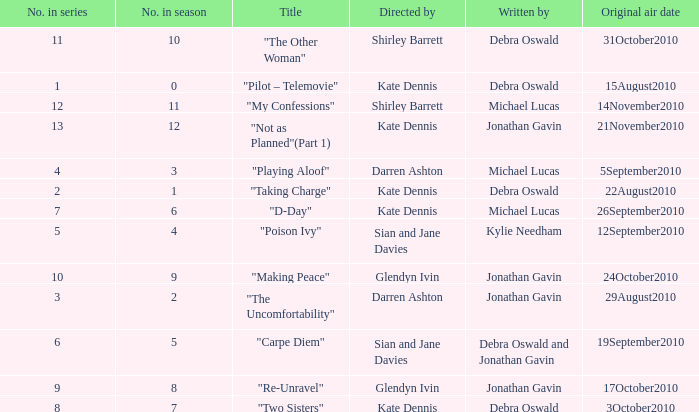When did "My Confessions" first air? 14November2010. 